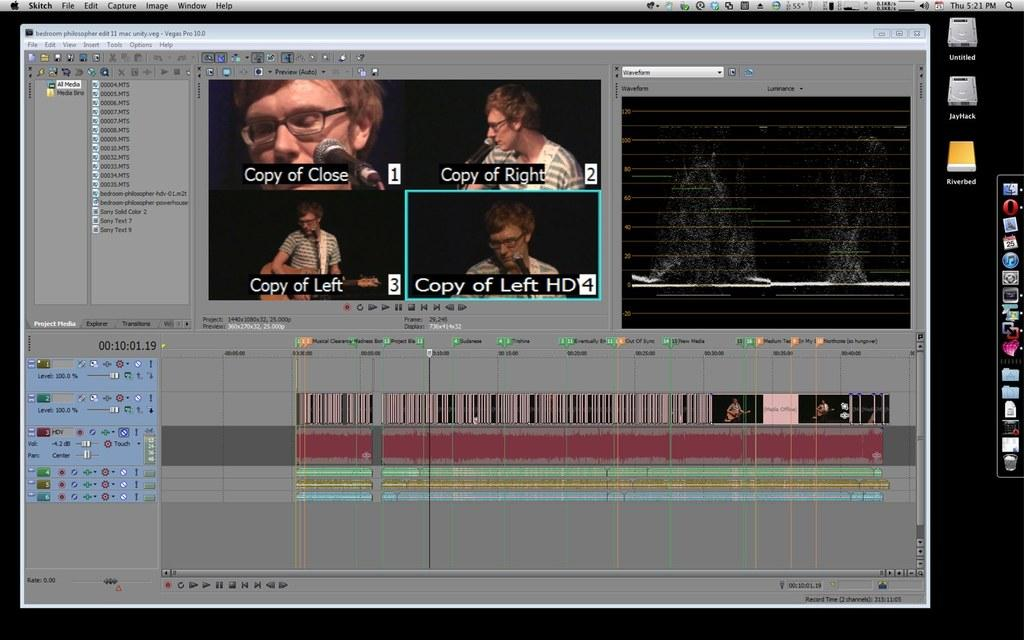What is the main subject of the image? The main subject of the image is a screenshot of a monitor. What can be seen on the monitor? There are icons, a dialogue box, and other unspecified elements in the image. Can you describe the dialogue box in the image? There is a dialogue box in the image with text, a person, and a microphone (mic) represented. What is the person doing in the dialogue box? The person is represented in the dialogue box, but their specific action is not clear from the provided facts. Can you tell me how many geese are visible in the image? There are no geese present in the image; it is a screenshot of a monitor with various icons, a dialogue box, and other unspecified elements. 